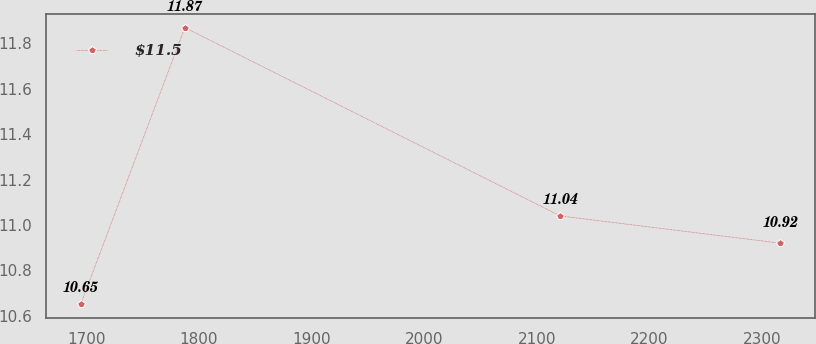Convert chart to OTSL. <chart><loc_0><loc_0><loc_500><loc_500><line_chart><ecel><fcel>$11.5<nl><fcel>1695.04<fcel>10.65<nl><fcel>1787.5<fcel>11.87<nl><fcel>2120.98<fcel>11.04<nl><fcel>2316.41<fcel>10.92<nl></chart> 